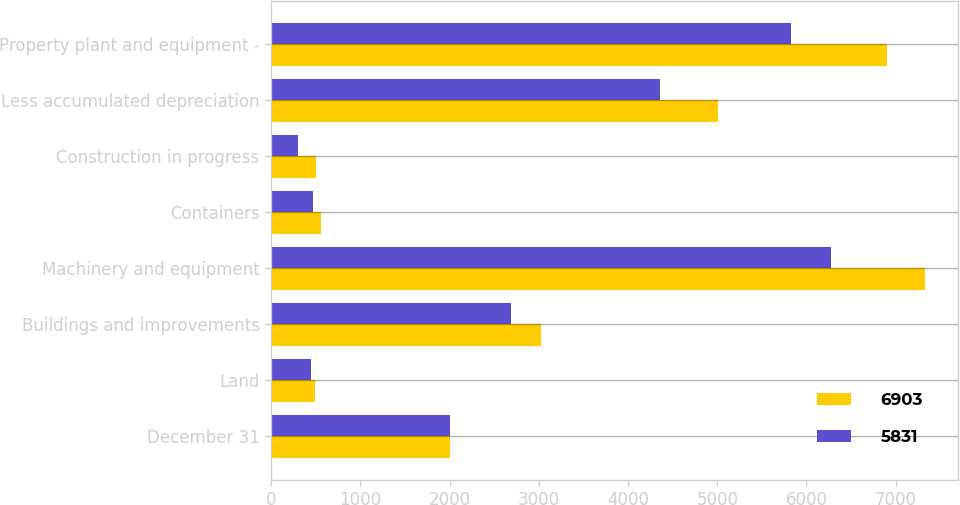Convert chart to OTSL. <chart><loc_0><loc_0><loc_500><loc_500><stacked_bar_chart><ecel><fcel>December 31<fcel>Land<fcel>Buildings and improvements<fcel>Machinery and equipment<fcel>Containers<fcel>Construction in progress<fcel>Less accumulated depreciation<fcel>Property plant and equipment -<nl><fcel>6903<fcel>2006<fcel>495<fcel>3020<fcel>7333<fcel>556<fcel>507<fcel>5008<fcel>6903<nl><fcel>5831<fcel>2005<fcel>447<fcel>2692<fcel>6271<fcel>468<fcel>306<fcel>4353<fcel>5831<nl></chart> 